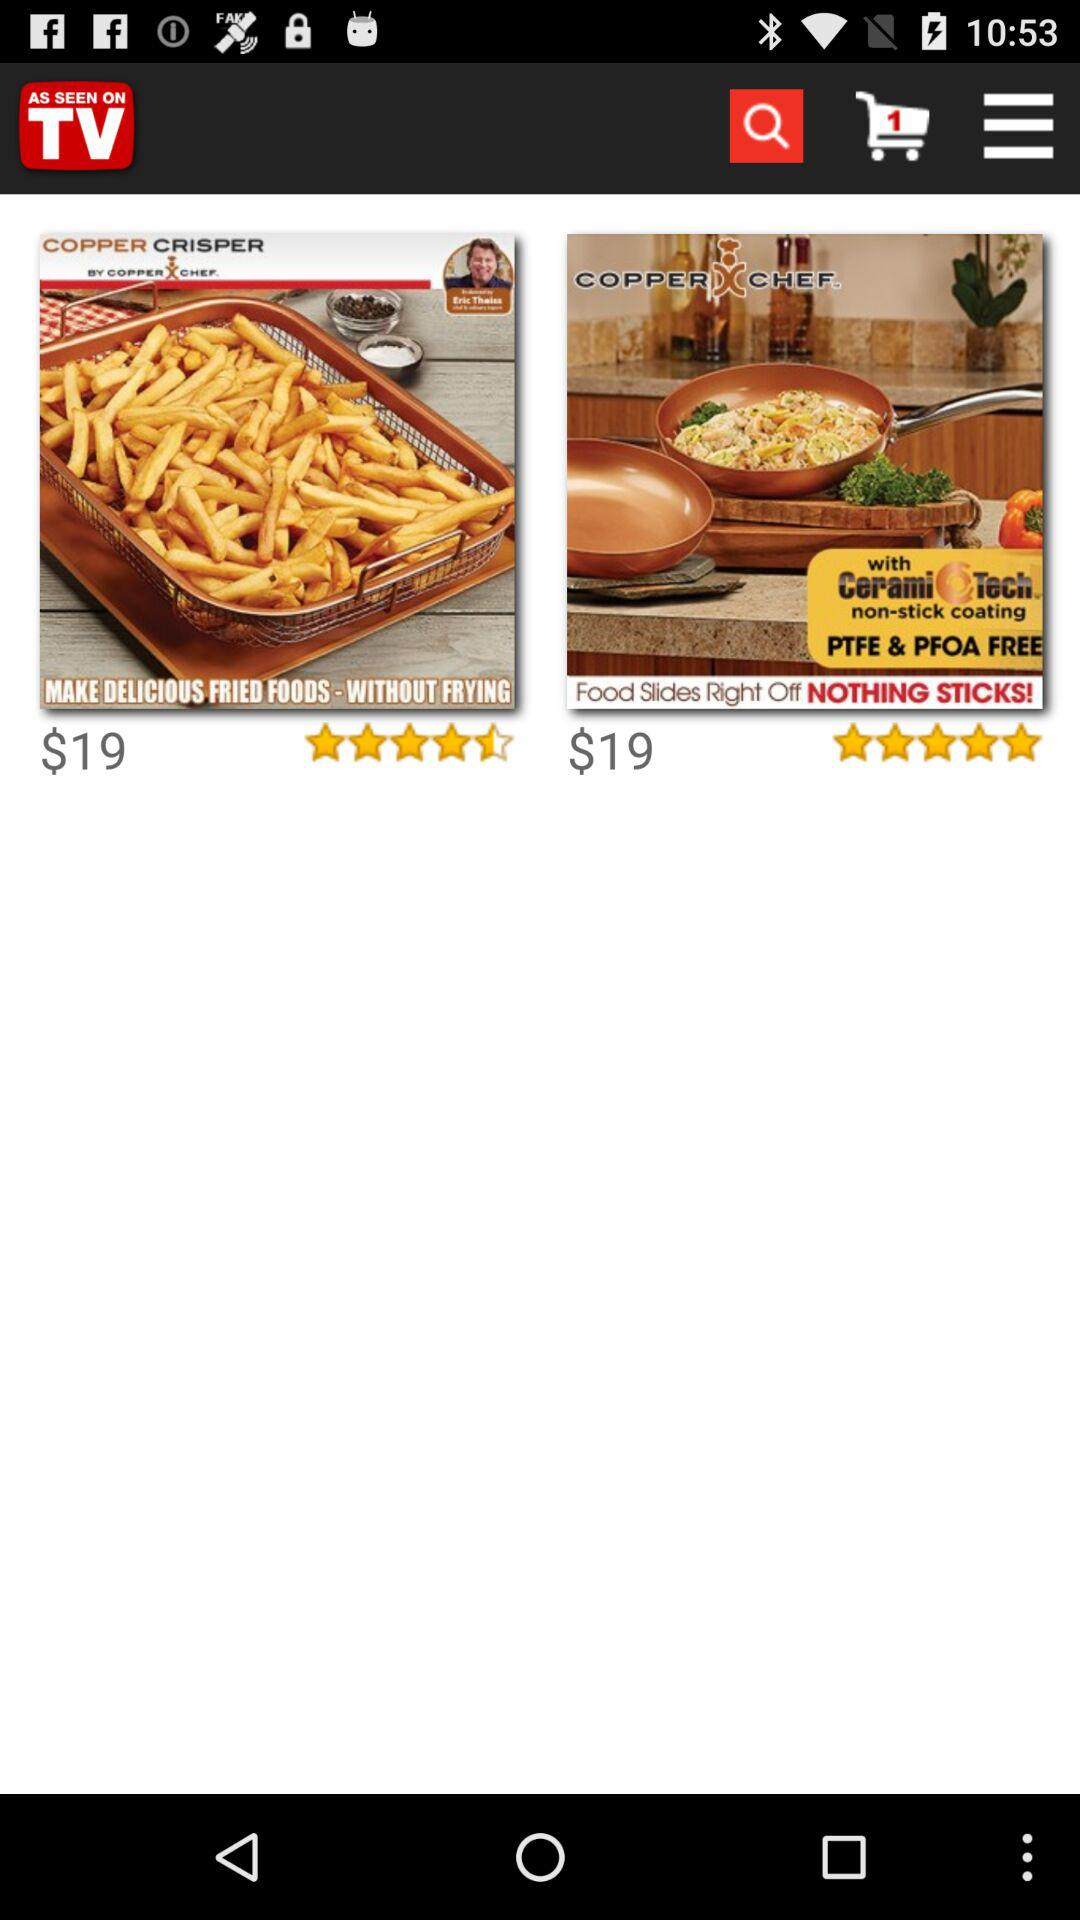How many items are there in the cart? There is 1 item in the cart. 